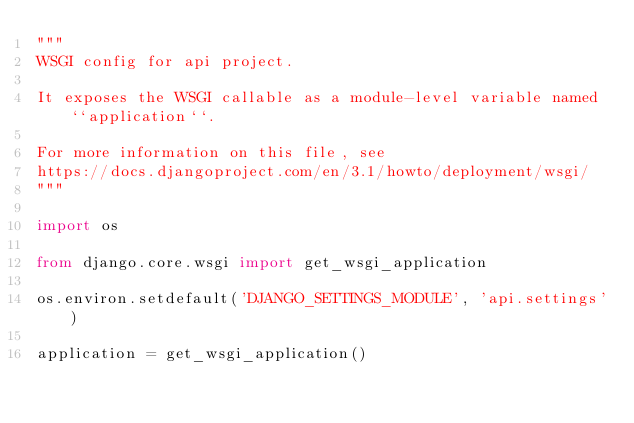Convert code to text. <code><loc_0><loc_0><loc_500><loc_500><_Python_>"""
WSGI config for api project.

It exposes the WSGI callable as a module-level variable named ``application``.

For more information on this file, see
https://docs.djangoproject.com/en/3.1/howto/deployment/wsgi/
"""

import os

from django.core.wsgi import get_wsgi_application

os.environ.setdefault('DJANGO_SETTINGS_MODULE', 'api.settings')

application = get_wsgi_application()
</code> 